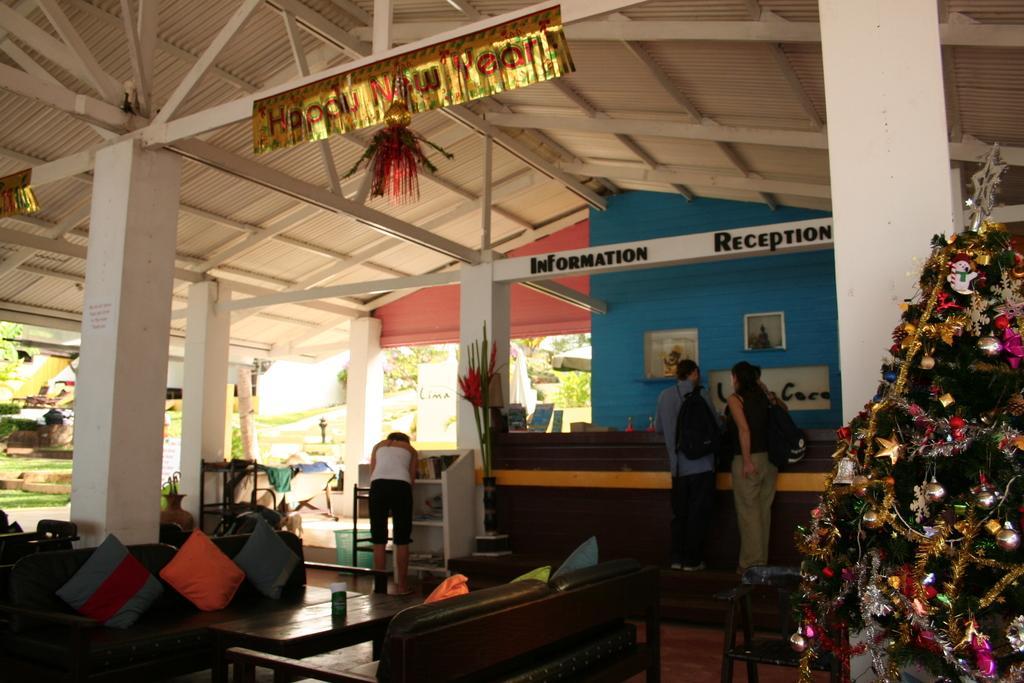In one or two sentences, can you explain what this image depicts? In this picture in the center there is a table, on the table there is an object which is black and white in colour, and there are sofas with cushions on it. In the background there are persons standing. On the wall there are frames and there is grass on the ground and there are trees and there is some text written on the wall. On the right side there is tree. On the top in the center there is a poster hanging with some text written on it. 